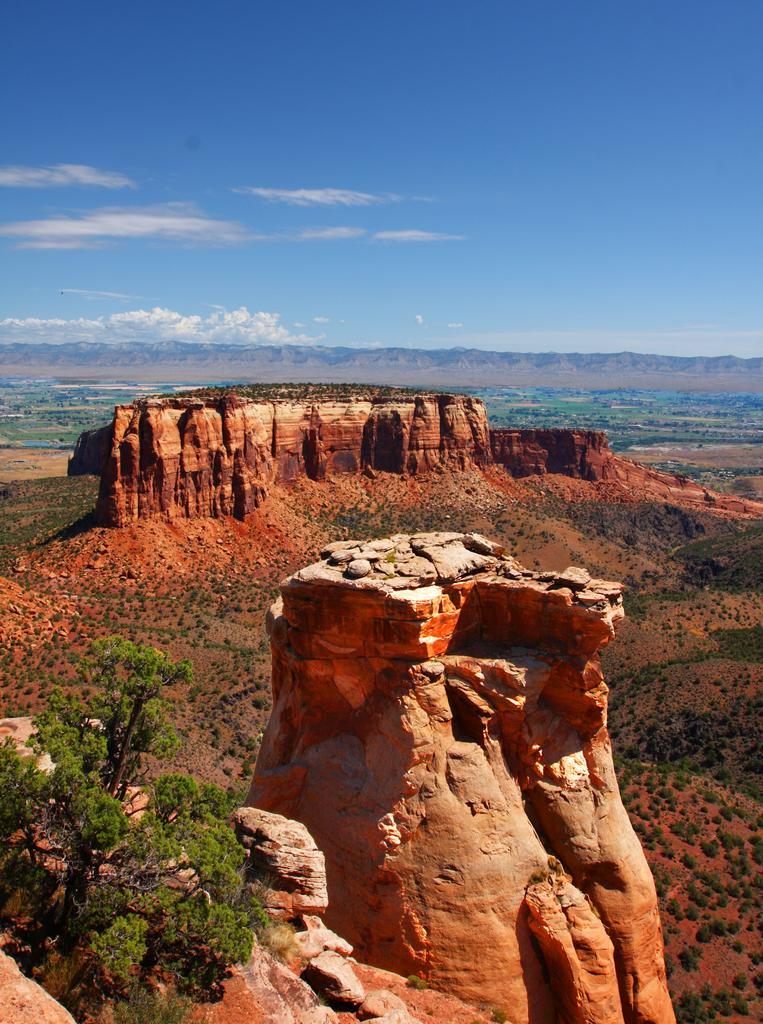What type of natural formation is visible in the image? There are mountain cliffs in the image. What other natural elements can be seen in the image? There is a tree in the image. What is visible in the background of the image? The background of the image includes mountains. What is visible at the top of the image? The sky is visible at the top of the image. What type of hair can be seen on the tree in the image? There is no hair present on the tree in the image; it is a natural element with leaves and branches. What type of arch can be seen in the image? There is no arch present in the image; it features mountain cliffs, a tree, mountains in the background, and the sky. 